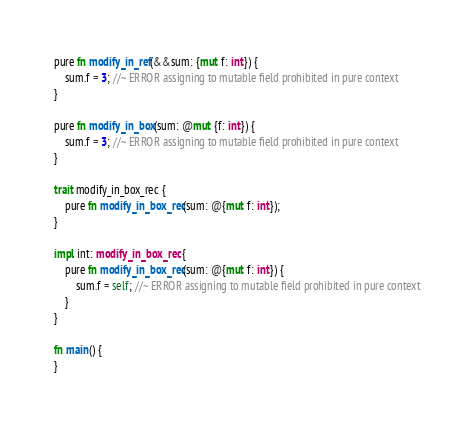<code> <loc_0><loc_0><loc_500><loc_500><_Rust_>pure fn modify_in_ref(&&sum: {mut f: int}) {
    sum.f = 3; //~ ERROR assigning to mutable field prohibited in pure context
}

pure fn modify_in_box(sum: @mut {f: int}) {
    sum.f = 3; //~ ERROR assigning to mutable field prohibited in pure context
}

trait modify_in_box_rec {
    pure fn modify_in_box_rec(sum: @{mut f: int});
}

impl int: modify_in_box_rec {
    pure fn modify_in_box_rec(sum: @{mut f: int}) {
        sum.f = self; //~ ERROR assigning to mutable field prohibited in pure context
    }
}

fn main() {
}
</code> 